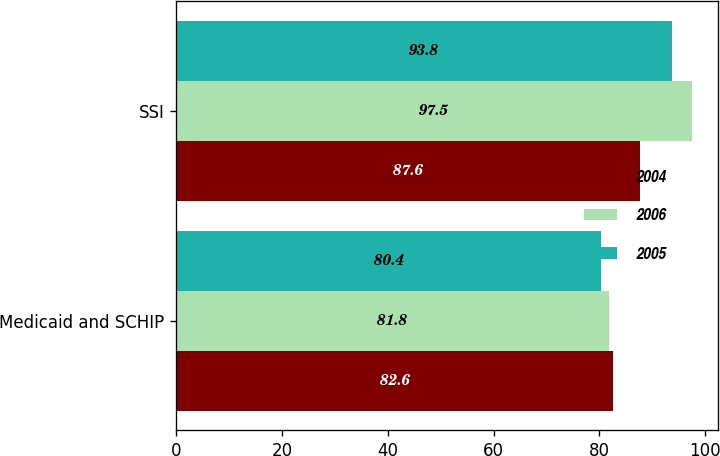Convert chart to OTSL. <chart><loc_0><loc_0><loc_500><loc_500><stacked_bar_chart><ecel><fcel>Medicaid and SCHIP<fcel>SSI<nl><fcel>2004<fcel>82.6<fcel>87.6<nl><fcel>2006<fcel>81.8<fcel>97.5<nl><fcel>2005<fcel>80.4<fcel>93.8<nl></chart> 